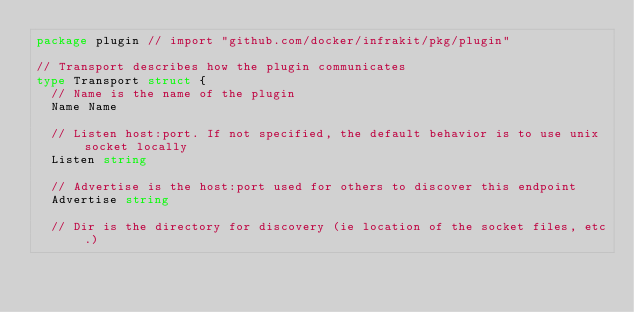Convert code to text. <code><loc_0><loc_0><loc_500><loc_500><_Go_>package plugin // import "github.com/docker/infrakit/pkg/plugin"

// Transport describes how the plugin communicates
type Transport struct {
	// Name is the name of the plugin
	Name Name

	// Listen host:port. If not specified, the default behavior is to use unix socket locally
	Listen string

	// Advertise is the host:port used for others to discover this endpoint
	Advertise string

	// Dir is the directory for discovery (ie location of the socket files, etc.)</code> 